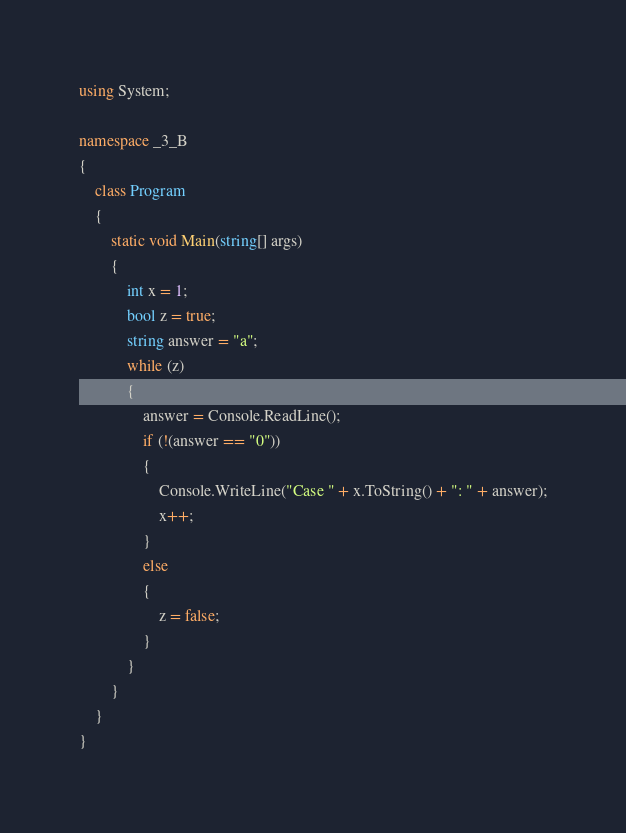Convert code to text. <code><loc_0><loc_0><loc_500><loc_500><_C#_>using System;

namespace _3_B
{
    class Program
    {
        static void Main(string[] args)
        {
            int x = 1;
            bool z = true;
            string answer = "a";
            while (z)
            {
                answer = Console.ReadLine();
                if (!(answer == "0"))
                {
                    Console.WriteLine("Case " + x.ToString() + ": " + answer);
                    x++;
                }
                else
                {
                    z = false;
                }
            }
        }
    }
}</code> 